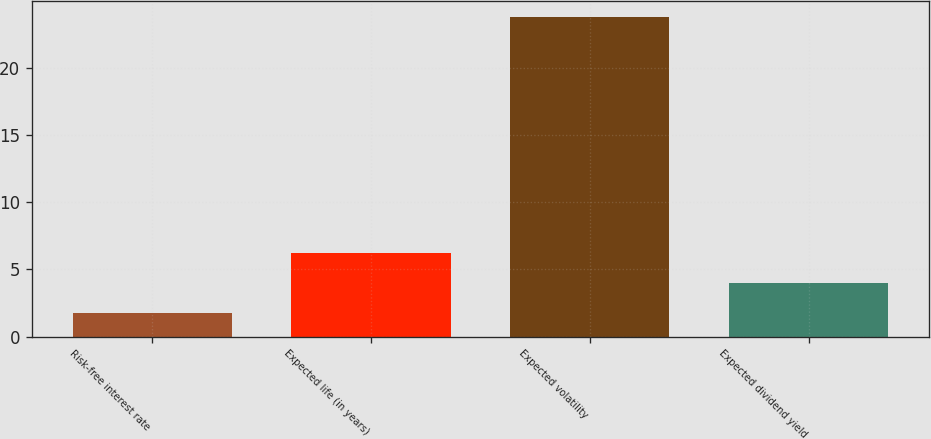<chart> <loc_0><loc_0><loc_500><loc_500><bar_chart><fcel>Risk-free interest rate<fcel>Expected life (in years)<fcel>Expected volatility<fcel>Expected dividend yield<nl><fcel>1.78<fcel>6.18<fcel>23.75<fcel>3.98<nl></chart> 